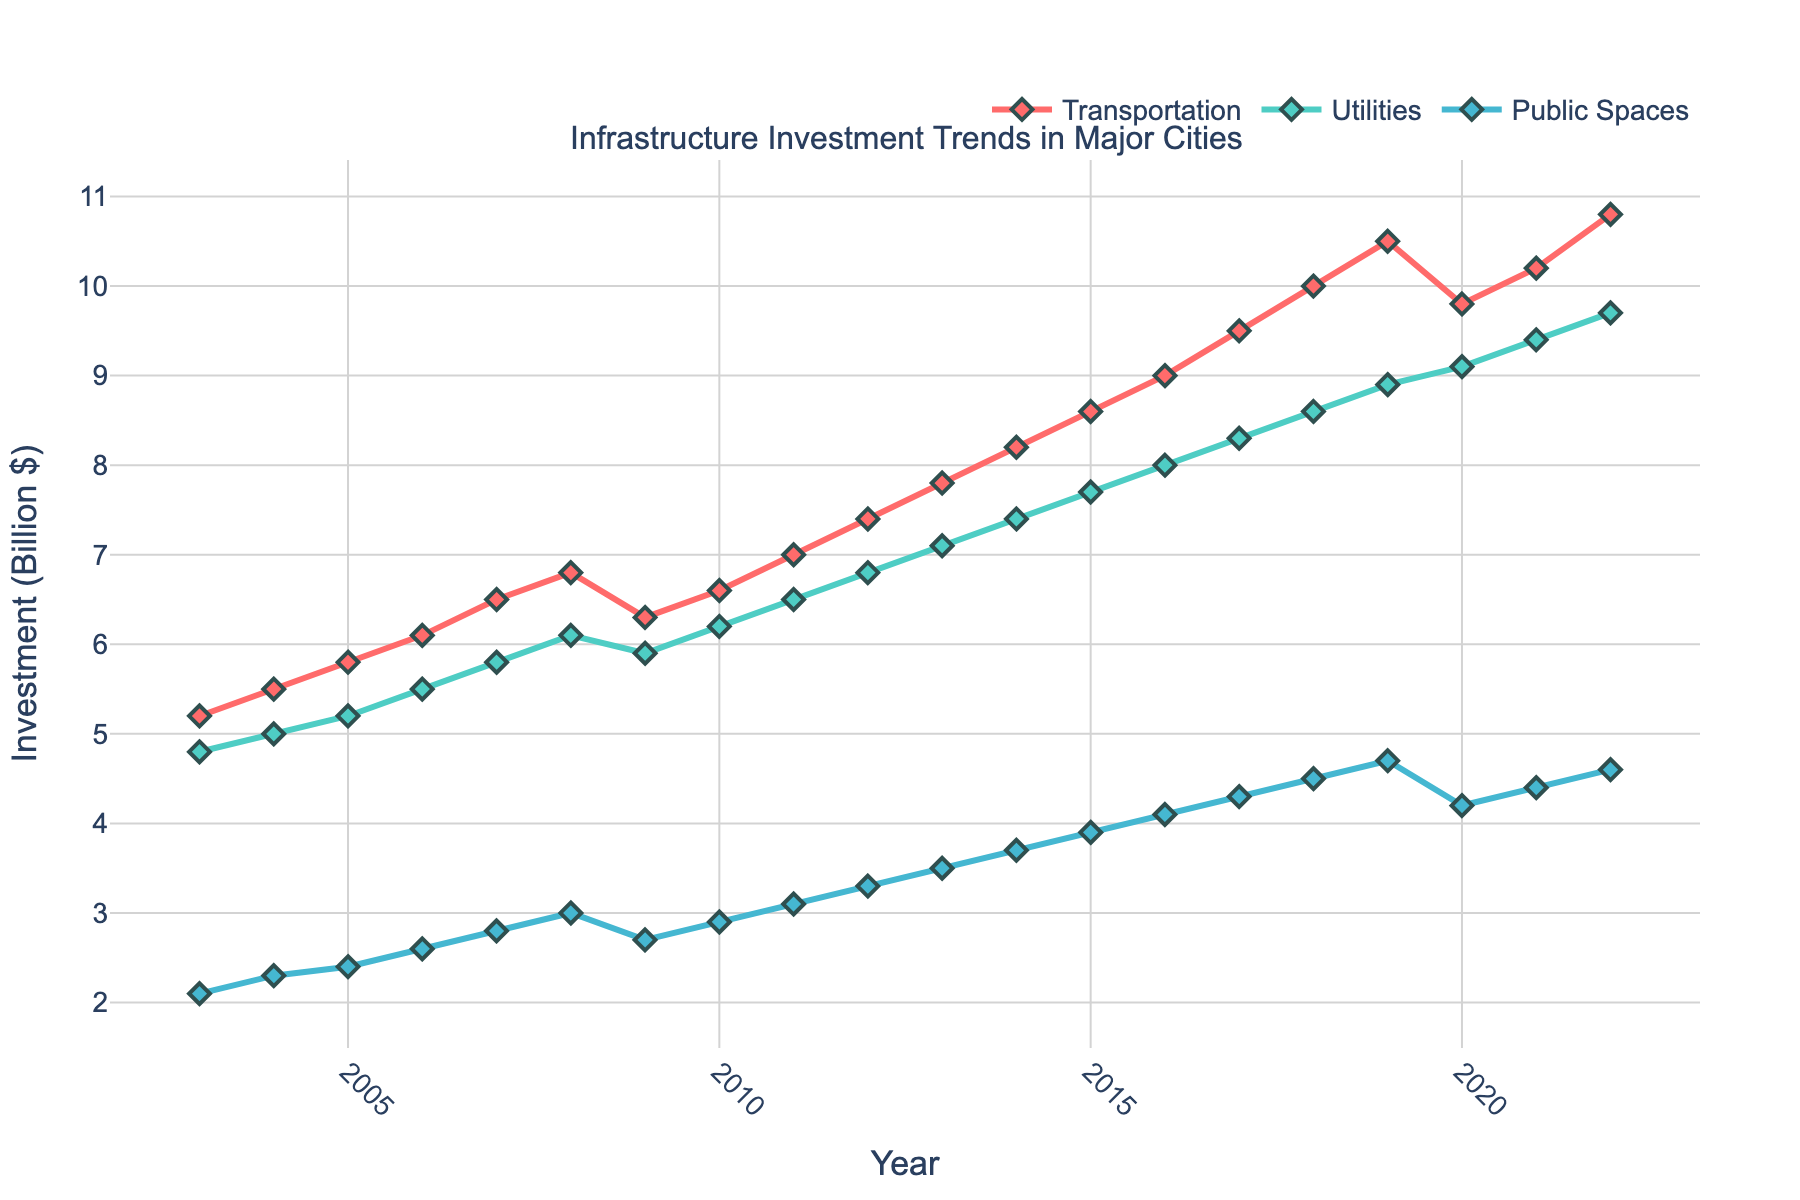What's the average investment in Transportation between 2003 and 2022? Add up all the investment values in Transportation from 2003 to 2022 and divide by the number of years (20). Calculation: (sum of values) / 20 = (5.2 + 5.5 + 5.8 + 6.1 + 6.5 + 6.8 + 6.3 + 6.6 + 7.0 + 7.4 + 7.8 + 8.2 + 8.6 + 9.0 + 9.5 + 10.0 + 10.5 + 9.8 + 10.2 + 10.8) / 20 = 7.645
Answer: 7.645 Which sector experienced the highest investment growth from 2003 to 2022? Compare the investment values of each sector in 2003 with those in 2022. Calculate the growth for each sector and compare them. The growth for Transportation is 10.8 - 5.2 = 5.6, for Utilities is 9.7 - 4.8 = 4.9, and for Public Spaces is 4.6 - 2.1 = 2.5.
Answer: Transportation In which year did Utilities investment surpass Public Spaces investment by more than 3 billion dollars? Check the difference between Utilities and Public Spaces investments year by year and identify the first year where the difference is greater than 3 billion dollars. In 2013, Utilities investment (7.1) - Public Spaces investment (3.5) = 3.6 billion dollars, which is the first instance.
Answer: 2013 How did the investment in Public Spaces from 2019 to 2020 change, and what was the percentage change? Calculate the difference in investment from 2019 to 2020 (4.7 - 4.2) and divide by the 2019 value, then multiply by 100 to get the percentage change. Percentage change: ((4.2 - 4.7) / 4.7) * 100 = -10.64%
Answer: -10.64% Which year had the highest total investment across all sectors, and what was the total investment? Sum the investments across all sectors for each year and identify the year with the highest total. For 2022, Total investment = Transportation (10.8) + Utilities (9.7) + Public Spaces (4.6) = 25.1 billion dollars, which is the highest.
Answer: 2022, 25.1 Compare the investment trends in Transportation and Public Spaces. Which trend shows a steadier increase over the years? Visually inspect the lines for Transportation and Public Spaces. Transportation shows a relatively consistent upward trend except for a small dip in 2009 and 2020, while Public Spaces has a steadier increase with smaller fluctuations.
Answer: Public Spaces What is the cumulative investment in Utilities from 2008 to 2015? Sum up the investment values in Utilities from 2008 to 2015. Calculation: 6.1 + 5.9 + 6.2 + 6.5 + 6.8 + 7.1 + 7.4 + 7.7 = 53.7 billion dollars
Answer: 53.7 Which year shows a decline in Transportation investment, and what is the value of the decline? Identify the years where the value of Transportation investment decreases compared to the previous year. The decline happens in 2009 from 6.8 to 6.3, a decline of (6.8 - 6.3) = 0.5 billion dollars.
Answer: 2009, 0.5 How much more was invested in Utilities compared to Public Spaces in 2022? Subtract the 2022 investment value of Public Spaces from that of Utilities: Utilities (9.7) - Public Spaces (4.6) = 5.1 billion dollars
Answer: 5.1 